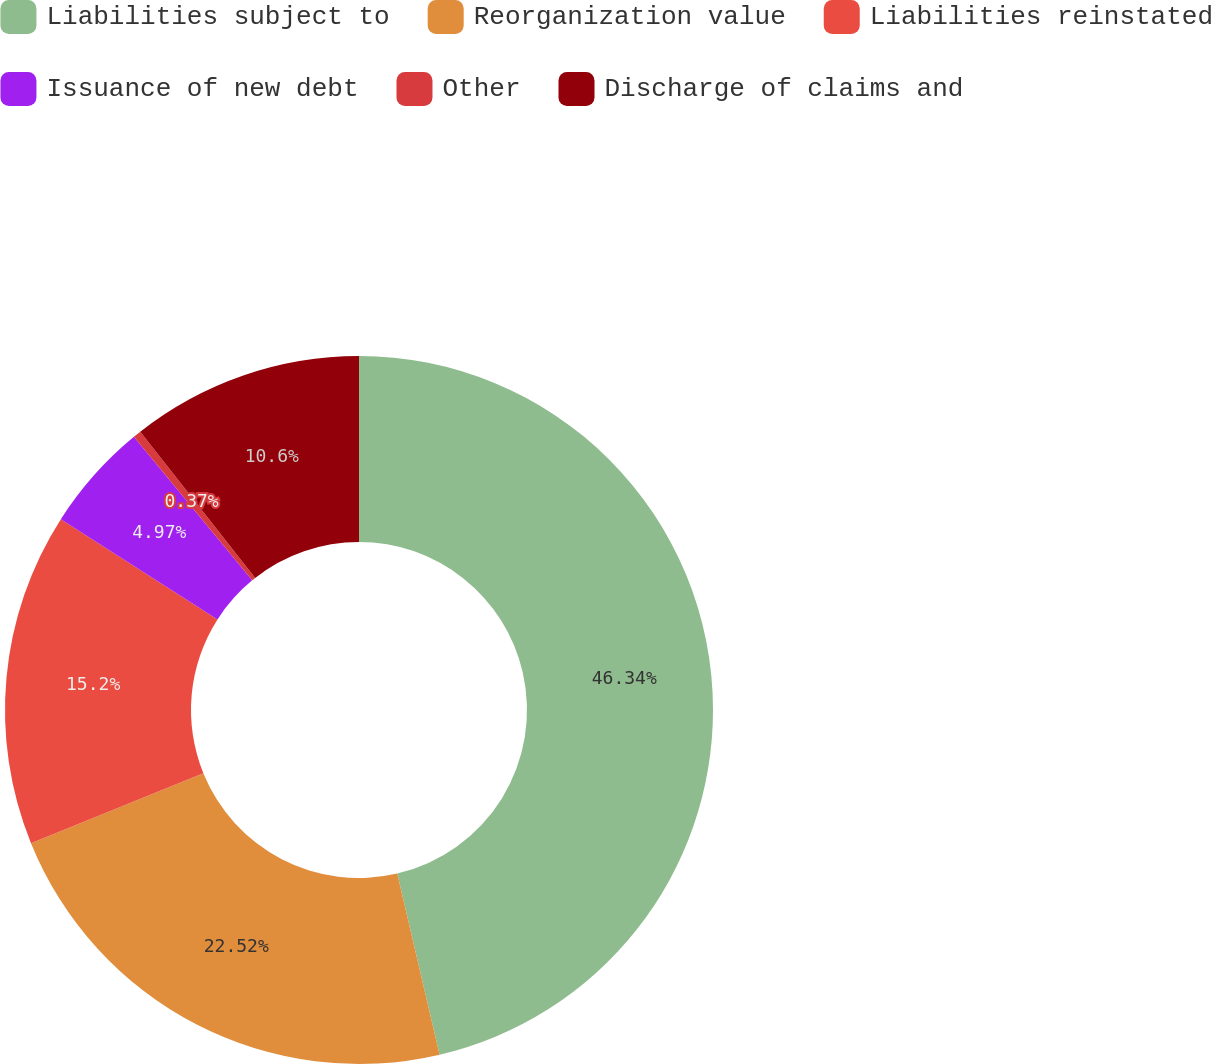<chart> <loc_0><loc_0><loc_500><loc_500><pie_chart><fcel>Liabilities subject to<fcel>Reorganization value<fcel>Liabilities reinstated<fcel>Issuance of new debt<fcel>Other<fcel>Discharge of claims and<nl><fcel>46.35%<fcel>22.52%<fcel>15.2%<fcel>4.97%<fcel>0.37%<fcel>10.6%<nl></chart> 